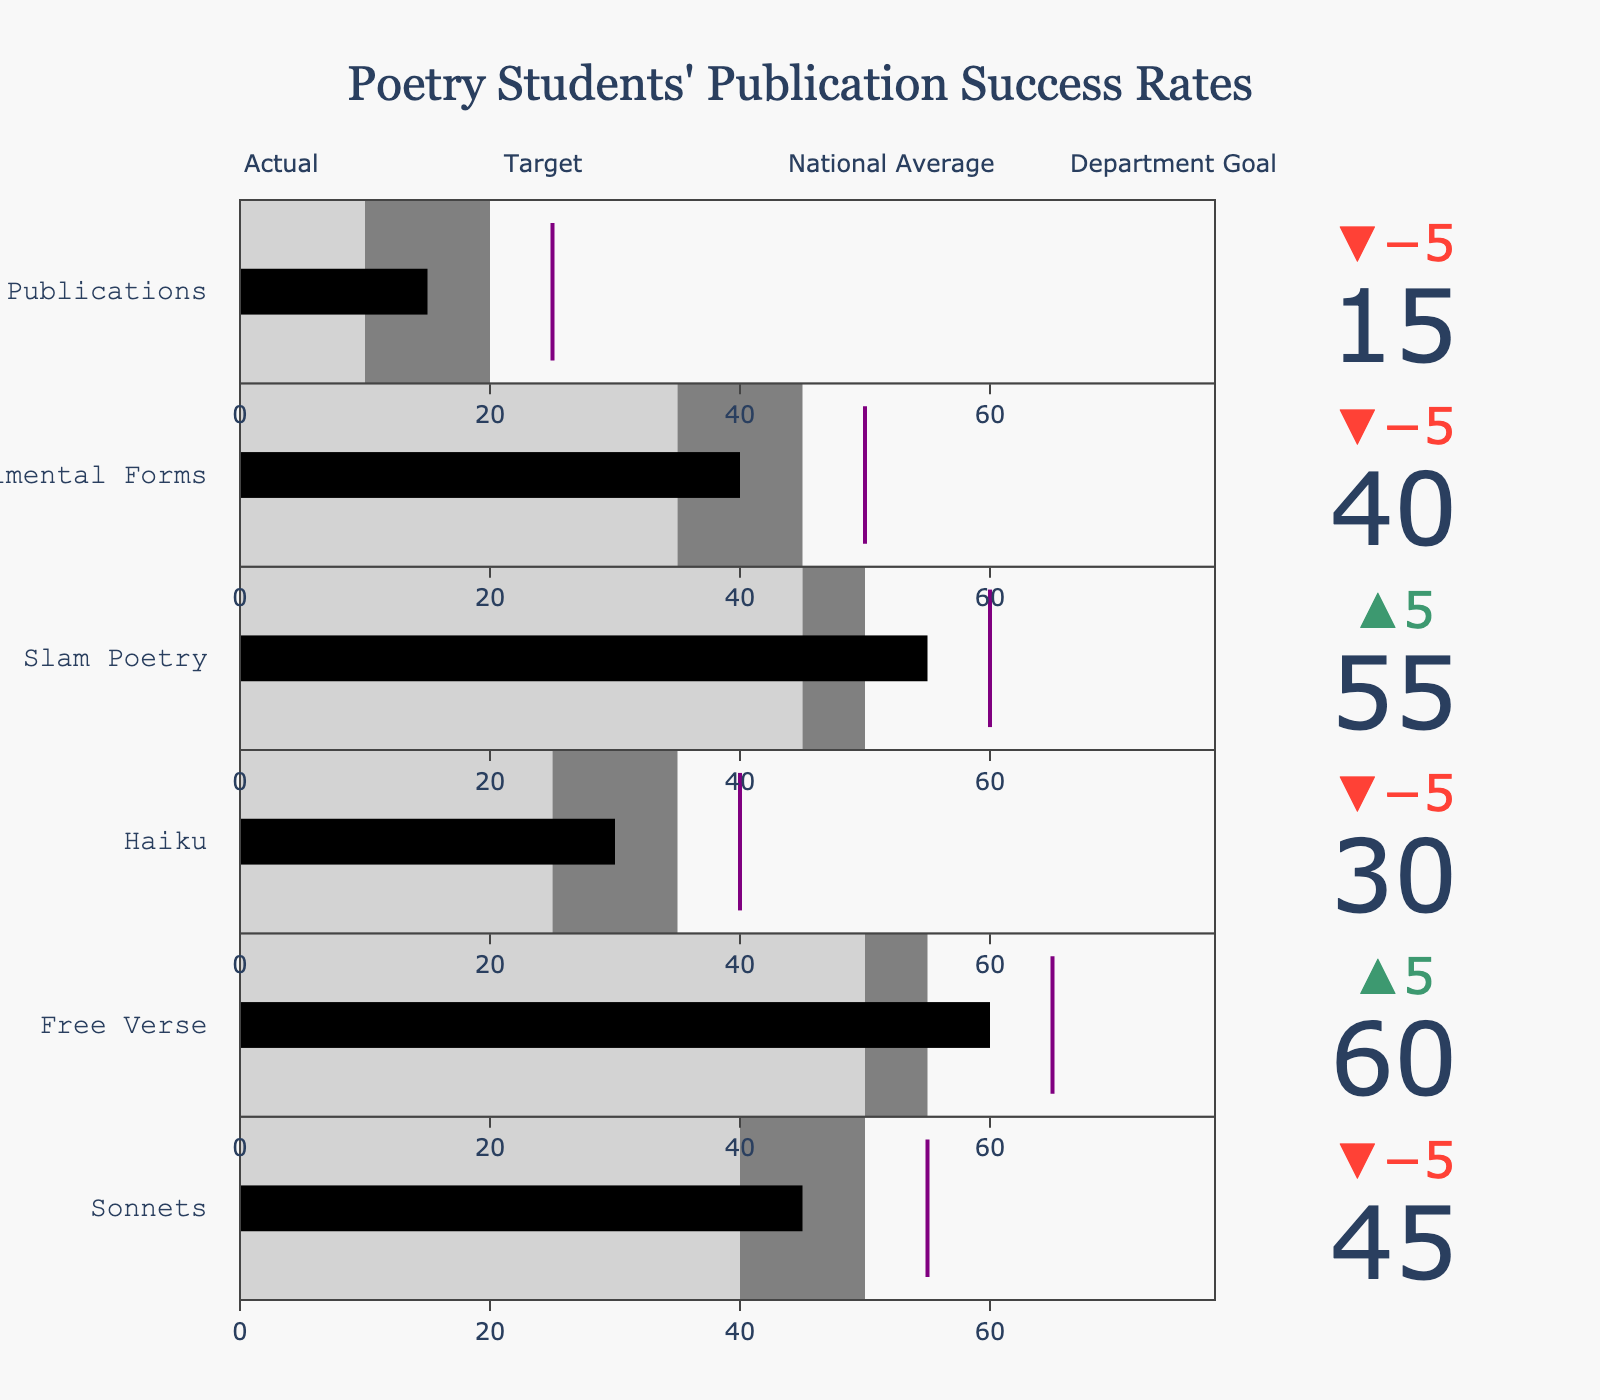How many categories are displayed in the bullet chart? Count the number of categories listed in the figure.
Answer: 6 What is the actual publication success rate for Free Verse? Identify the success rate mentioned for Free Verse in the 'Actual' column.
Answer: 60 Which category has the lowest department goal? Compare the department goals for all categories and find the minimum value.
Answer: Chapbook Publications By how much did Sonnets fall short of the department goal? Subtract the actual success rate of Sonnets from the department goal. 55 - 45 = 10
Answer: 10 Which category exceeded its target by the largest margin? Calculate the difference between the 'Actual' and 'Target' for each category and find the largest positive difference. Free Verse: 60 - 55 = 5. Free Verse has the largest margin.
Answer: Free Verse How does the actual success rate of Slam Poetry compare with its national average? Find the actual success rate and the national average for Slam Poetry in the figure and compare them. Actual: 55, National Average: 45. Actual is greater than the national average.
Answer: Greater What is the overall range of department goals? Subtract the smallest department goal value from the largest one to find the range. Largest: 65 (Free Verse), Smallest: 25 (Chapbook Publications). Range = 65 - 25 = 40
Answer: 40 Which category is closest to meeting its department goal? Find the difference between the 'Actual' and 'Department Goal' for each category and identify the smallest value. Slam Poetry: 60 - 55 = 5. Slam Poetry is closest.
Answer: Slam Poetry Compare the actual publication rates between Sonnets and Experimental Forms. Identify the actual rates for both categories and compare them. Sonnets: 45, Experimental Forms: 40. Sonnets is higher.
Answer: Sonnets What is the average actual success rate across all categories? Sum up the actual success rates and divide by the number of categories. (45 + 60 + 30 + 55 + 40 + 15) / 6 = 245 / 6 ≈ 40.83
Answer: 40.83 